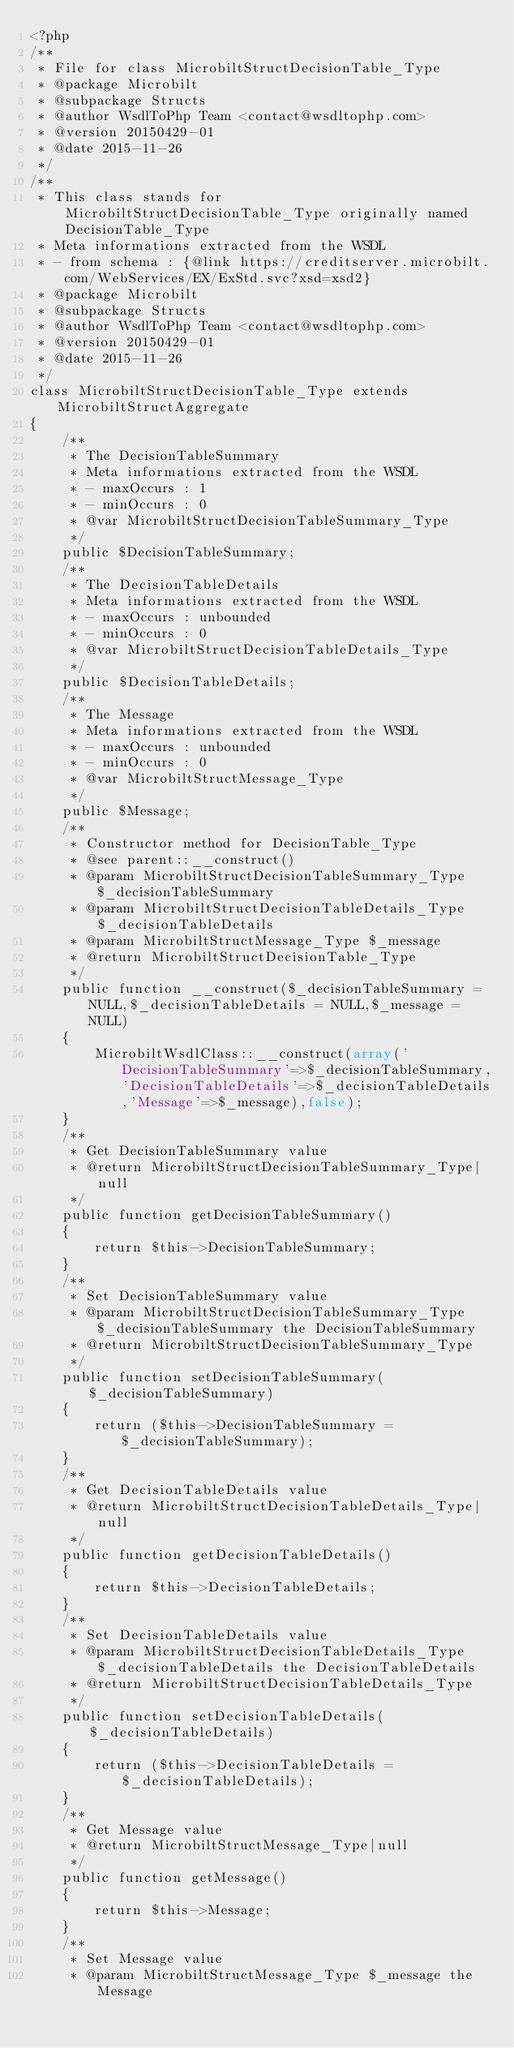Convert code to text. <code><loc_0><loc_0><loc_500><loc_500><_PHP_><?php
/**
 * File for class MicrobiltStructDecisionTable_Type
 * @package Microbilt
 * @subpackage Structs
 * @author WsdlToPhp Team <contact@wsdltophp.com>
 * @version 20150429-01
 * @date 2015-11-26
 */
/**
 * This class stands for MicrobiltStructDecisionTable_Type originally named DecisionTable_Type
 * Meta informations extracted from the WSDL
 * - from schema : {@link https://creditserver.microbilt.com/WebServices/EX/ExStd.svc?xsd=xsd2}
 * @package Microbilt
 * @subpackage Structs
 * @author WsdlToPhp Team <contact@wsdltophp.com>
 * @version 20150429-01
 * @date 2015-11-26
 */
class MicrobiltStructDecisionTable_Type extends MicrobiltStructAggregate
{
    /**
     * The DecisionTableSummary
     * Meta informations extracted from the WSDL
     * - maxOccurs : 1
     * - minOccurs : 0
     * @var MicrobiltStructDecisionTableSummary_Type
     */
    public $DecisionTableSummary;
    /**
     * The DecisionTableDetails
     * Meta informations extracted from the WSDL
     * - maxOccurs : unbounded
     * - minOccurs : 0
     * @var MicrobiltStructDecisionTableDetails_Type
     */
    public $DecisionTableDetails;
    /**
     * The Message
     * Meta informations extracted from the WSDL
     * - maxOccurs : unbounded
     * - minOccurs : 0
     * @var MicrobiltStructMessage_Type
     */
    public $Message;
    /**
     * Constructor method for DecisionTable_Type
     * @see parent::__construct()
     * @param MicrobiltStructDecisionTableSummary_Type $_decisionTableSummary
     * @param MicrobiltStructDecisionTableDetails_Type $_decisionTableDetails
     * @param MicrobiltStructMessage_Type $_message
     * @return MicrobiltStructDecisionTable_Type
     */
    public function __construct($_decisionTableSummary = NULL,$_decisionTableDetails = NULL,$_message = NULL)
    {
        MicrobiltWsdlClass::__construct(array('DecisionTableSummary'=>$_decisionTableSummary,'DecisionTableDetails'=>$_decisionTableDetails,'Message'=>$_message),false);
    }
    /**
     * Get DecisionTableSummary value
     * @return MicrobiltStructDecisionTableSummary_Type|null
     */
    public function getDecisionTableSummary()
    {
        return $this->DecisionTableSummary;
    }
    /**
     * Set DecisionTableSummary value
     * @param MicrobiltStructDecisionTableSummary_Type $_decisionTableSummary the DecisionTableSummary
     * @return MicrobiltStructDecisionTableSummary_Type
     */
    public function setDecisionTableSummary($_decisionTableSummary)
    {
        return ($this->DecisionTableSummary = $_decisionTableSummary);
    }
    /**
     * Get DecisionTableDetails value
     * @return MicrobiltStructDecisionTableDetails_Type|null
     */
    public function getDecisionTableDetails()
    {
        return $this->DecisionTableDetails;
    }
    /**
     * Set DecisionTableDetails value
     * @param MicrobiltStructDecisionTableDetails_Type $_decisionTableDetails the DecisionTableDetails
     * @return MicrobiltStructDecisionTableDetails_Type
     */
    public function setDecisionTableDetails($_decisionTableDetails)
    {
        return ($this->DecisionTableDetails = $_decisionTableDetails);
    }
    /**
     * Get Message value
     * @return MicrobiltStructMessage_Type|null
     */
    public function getMessage()
    {
        return $this->Message;
    }
    /**
     * Set Message value
     * @param MicrobiltStructMessage_Type $_message the Message</code> 